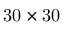<formula> <loc_0><loc_0><loc_500><loc_500>3 0 \times 3 0</formula> 